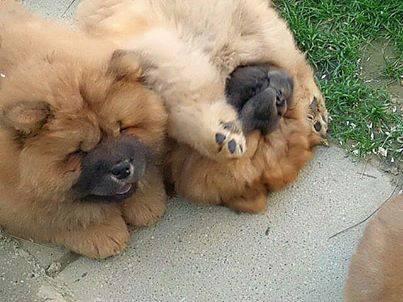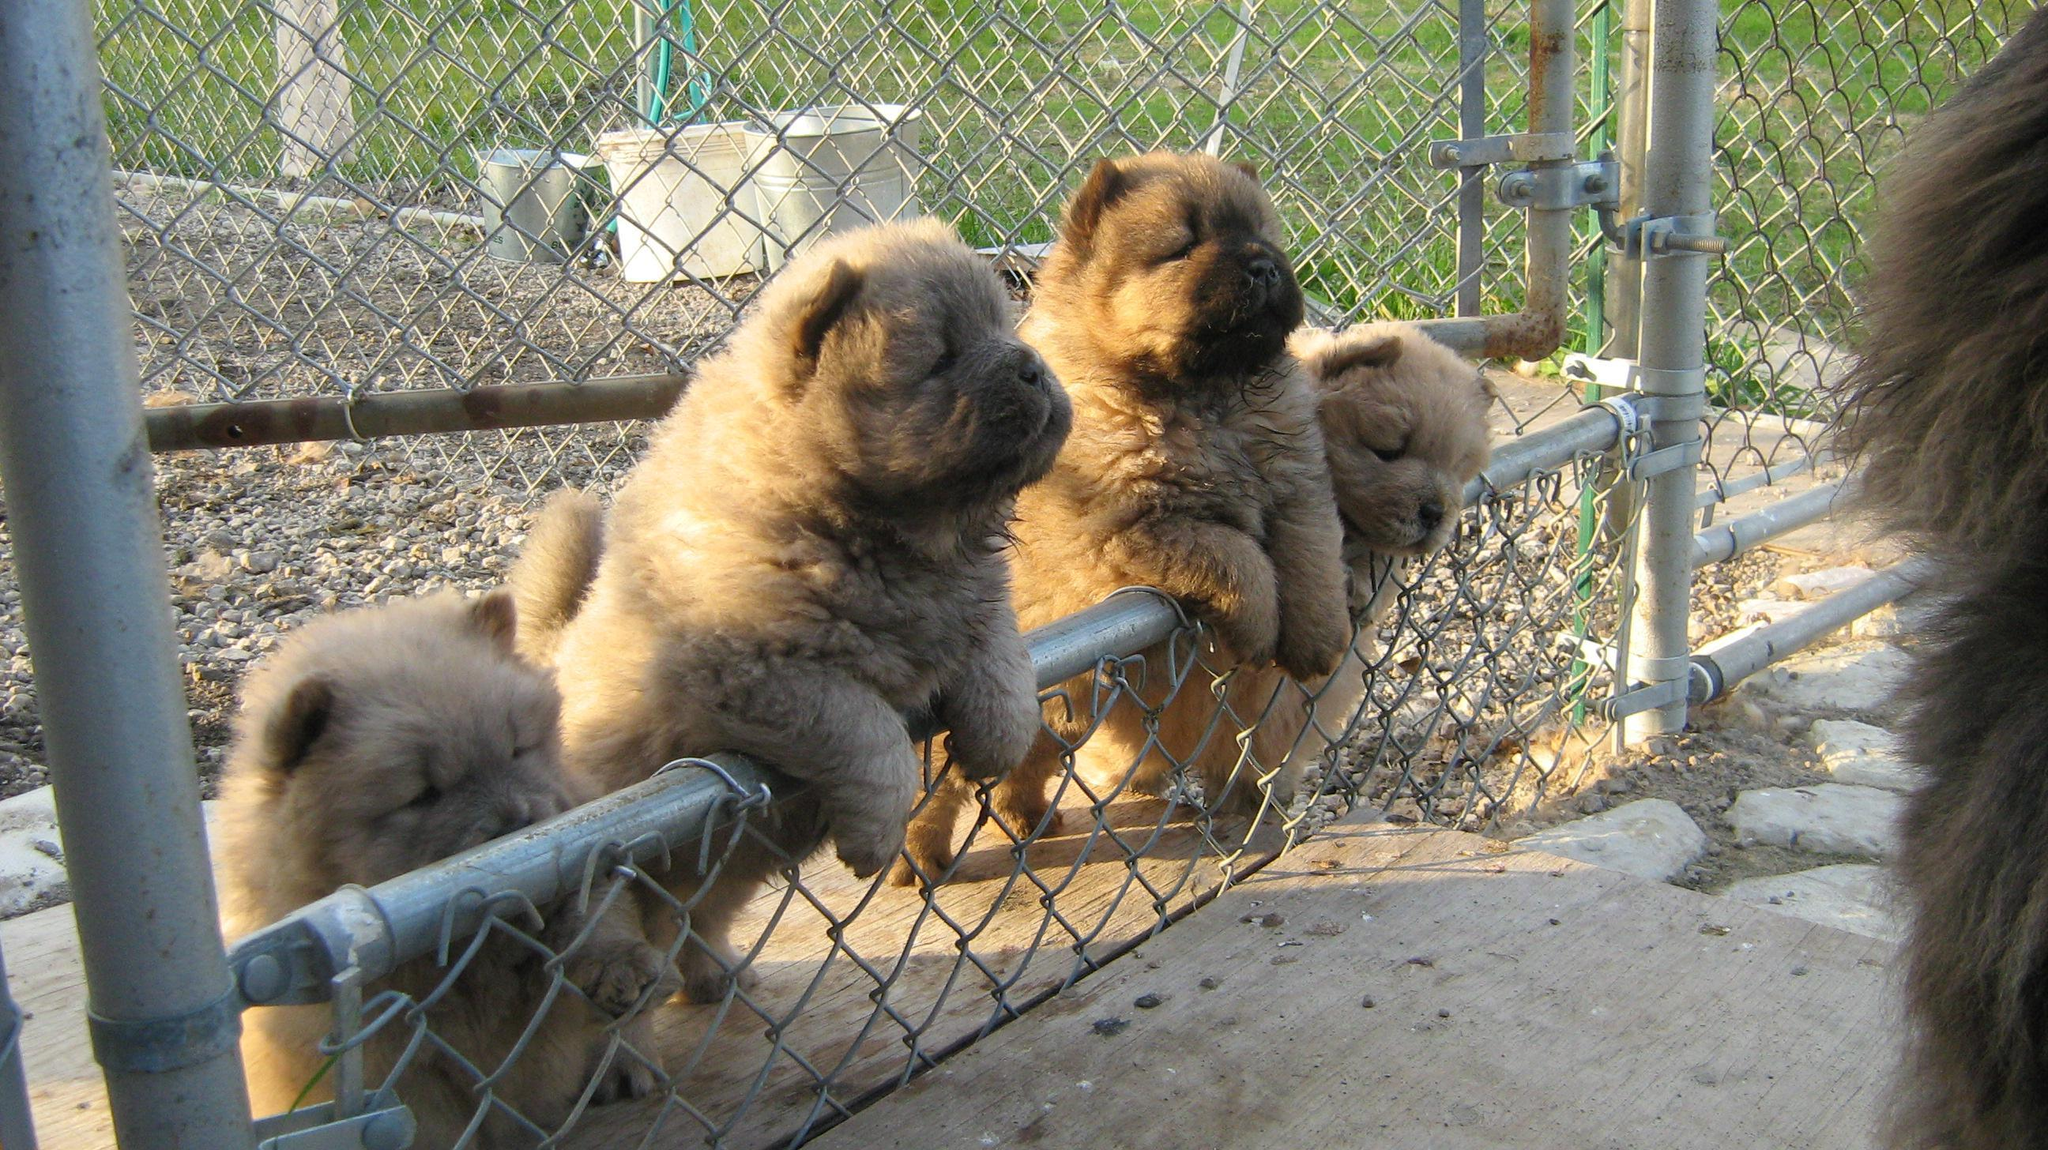The first image is the image on the left, the second image is the image on the right. Examine the images to the left and right. Is the description "There are more than 4 dogs." accurate? Answer yes or no. Yes. The first image is the image on the left, the second image is the image on the right. For the images displayed, is the sentence "There are no less than four dogs in one of the images." factually correct? Answer yes or no. Yes. 